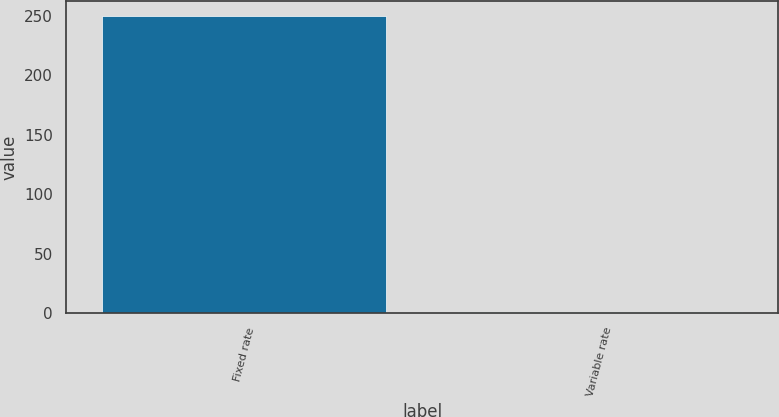Convert chart. <chart><loc_0><loc_0><loc_500><loc_500><bar_chart><fcel>Fixed rate<fcel>Variable rate<nl><fcel>250.2<fcel>0.7<nl></chart> 